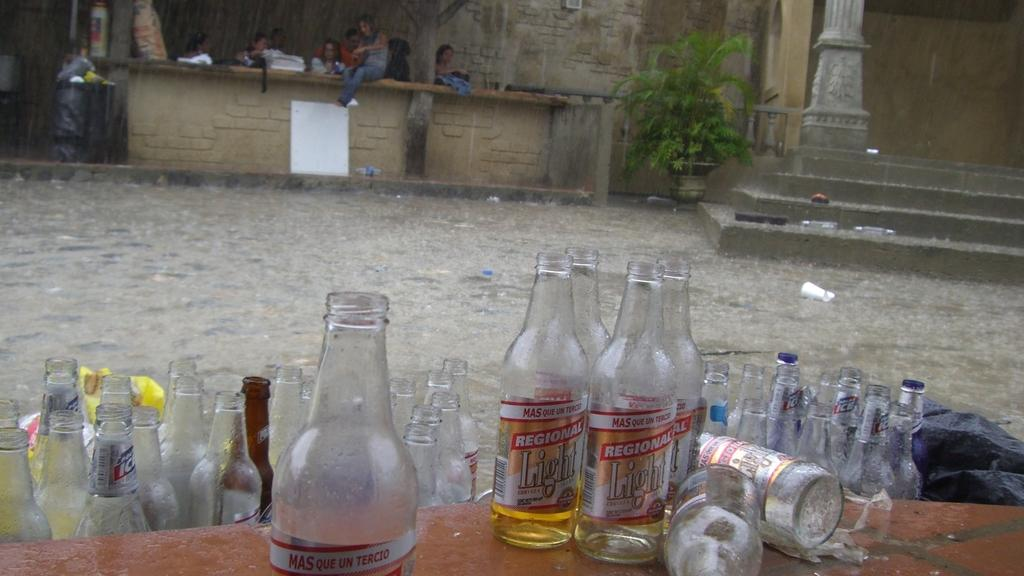<image>
Describe the image concisely. empty bottles of Regional Light cerveza on an outside table 